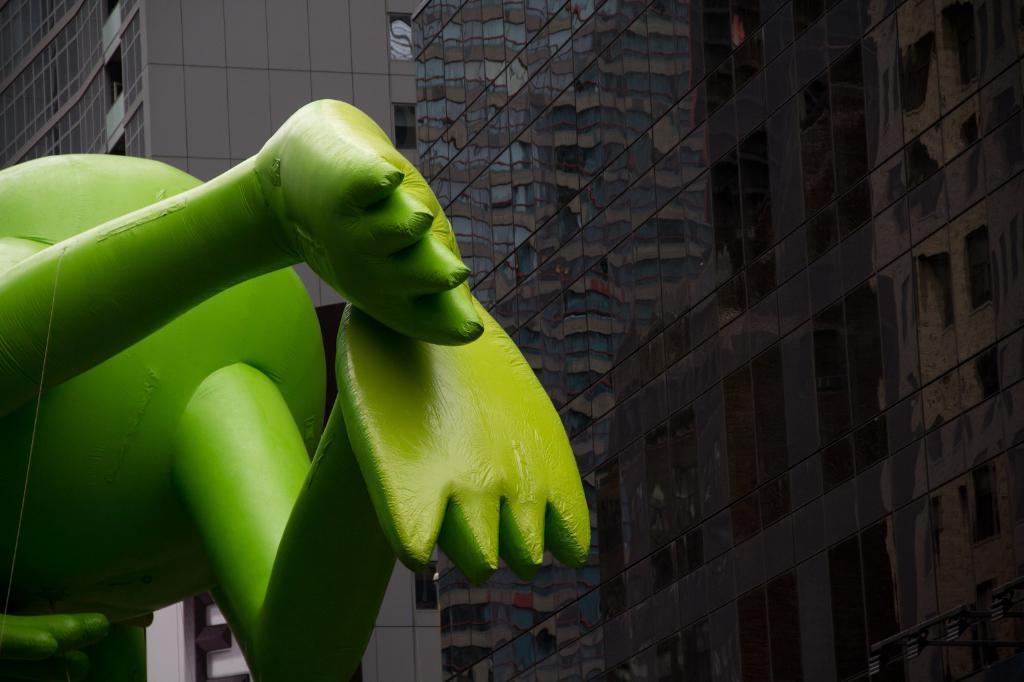Can you describe this image briefly? In this picture we can see a statue on the left side, in the background there is a building, we can see glasses of the building. 